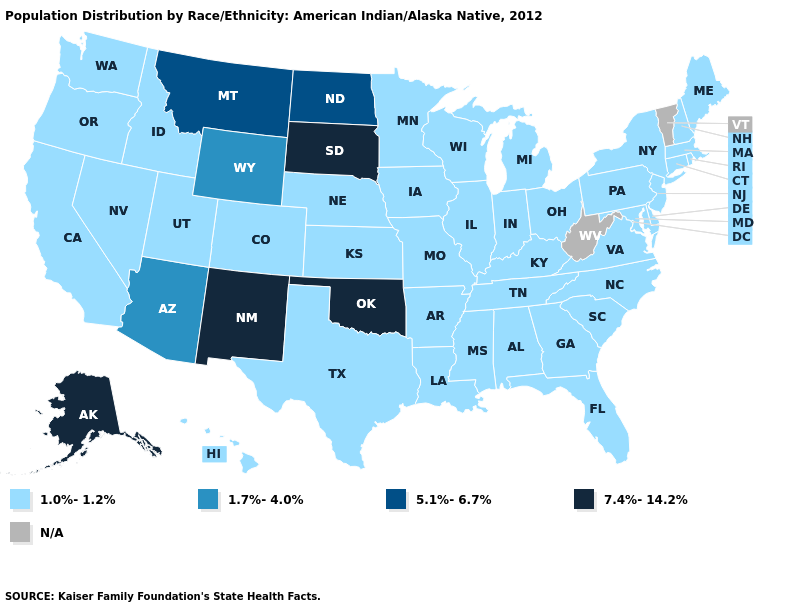Does the first symbol in the legend represent the smallest category?
Quick response, please. Yes. Name the states that have a value in the range N/A?
Give a very brief answer. Vermont, West Virginia. Does Indiana have the lowest value in the USA?
Concise answer only. Yes. Which states have the lowest value in the South?
Answer briefly. Alabama, Arkansas, Delaware, Florida, Georgia, Kentucky, Louisiana, Maryland, Mississippi, North Carolina, South Carolina, Tennessee, Texas, Virginia. Which states have the highest value in the USA?
Be succinct. Alaska, New Mexico, Oklahoma, South Dakota. What is the highest value in the USA?
Give a very brief answer. 7.4%-14.2%. Does Ohio have the highest value in the MidWest?
Quick response, please. No. What is the highest value in the USA?
Write a very short answer. 7.4%-14.2%. Which states hav the highest value in the South?
Concise answer only. Oklahoma. What is the highest value in the MidWest ?
Concise answer only. 7.4%-14.2%. Which states have the lowest value in the Northeast?
Be succinct. Connecticut, Maine, Massachusetts, New Hampshire, New Jersey, New York, Pennsylvania, Rhode Island. 